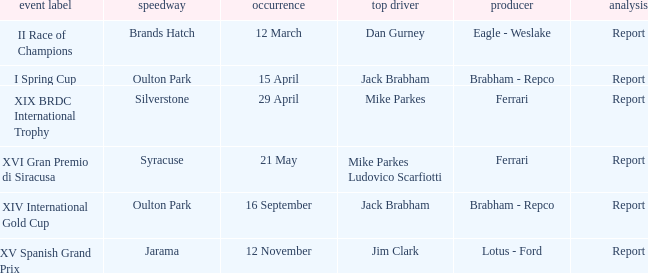What date was the xiv international gold cup? 16 September. 